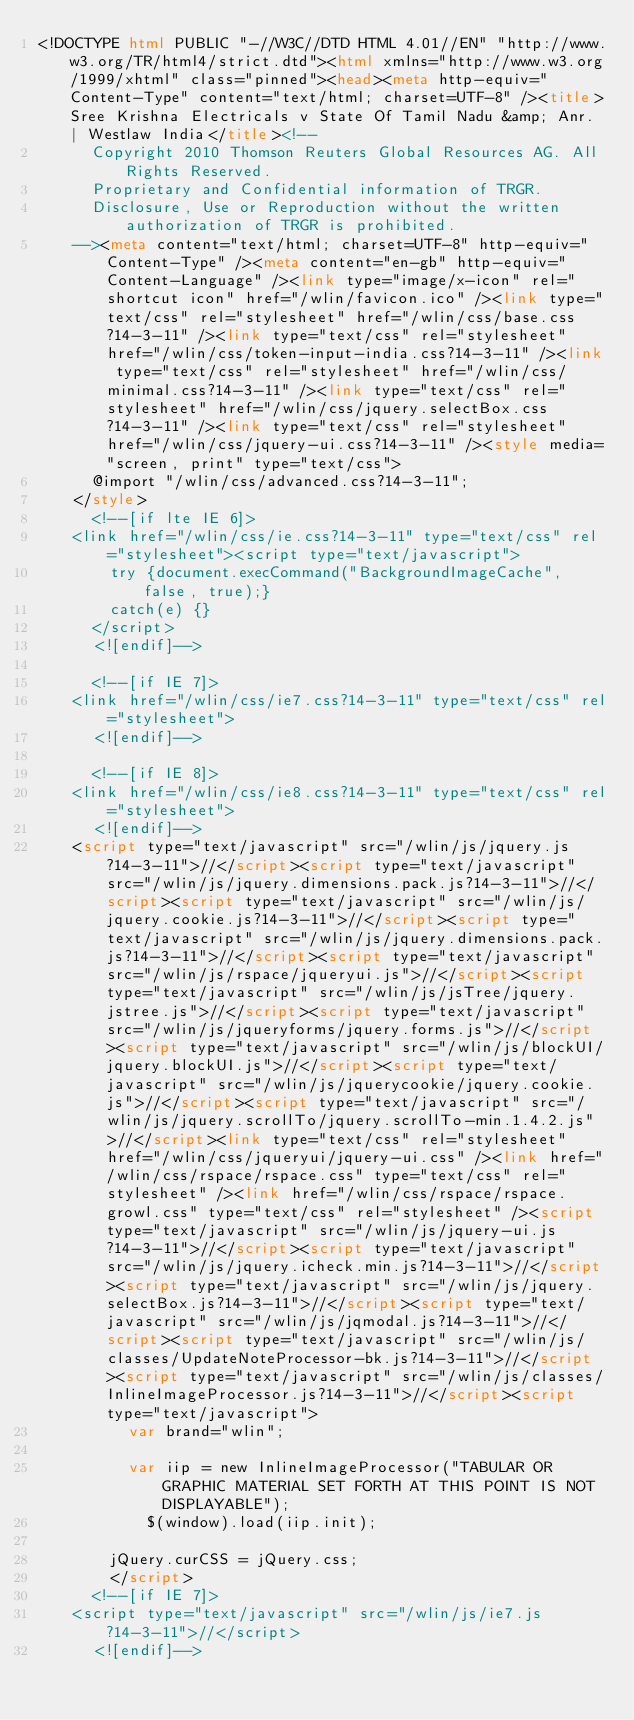Convert code to text. <code><loc_0><loc_0><loc_500><loc_500><_HTML_><!DOCTYPE html PUBLIC "-//W3C//DTD HTML 4.01//EN" "http://www.w3.org/TR/html4/strict.dtd"><html xmlns="http://www.w3.org/1999/xhtml" class="pinned"><head><meta http-equiv="Content-Type" content="text/html; charset=UTF-8" /><title>Sree Krishna Electricals v State Of Tamil Nadu &amp; Anr. | Westlaw India</title><!--
      Copyright 2010 Thomson Reuters Global Resources AG. All Rights Reserved.
      Proprietary and Confidential information of TRGR.
      Disclosure, Use or Reproduction without the written authorization of TRGR is prohibited.
    --><meta content="text/html; charset=UTF-8" http-equiv="Content-Type" /><meta content="en-gb" http-equiv="Content-Language" /><link type="image/x-icon" rel="shortcut icon" href="/wlin/favicon.ico" /><link type="text/css" rel="stylesheet" href="/wlin/css/base.css?14-3-11" /><link type="text/css" rel="stylesheet" href="/wlin/css/token-input-india.css?14-3-11" /><link type="text/css" rel="stylesheet" href="/wlin/css/minimal.css?14-3-11" /><link type="text/css" rel="stylesheet" href="/wlin/css/jquery.selectBox.css?14-3-11" /><link type="text/css" rel="stylesheet" href="/wlin/css/jquery-ui.css?14-3-11" /><style media="screen, print" type="text/css">
			@import "/wlin/css/advanced.css?14-3-11";
		</style>
			<!--[if lte IE 6]>
		<link href="/wlin/css/ie.css?14-3-11" type="text/css" rel="stylesheet"><script type="text/javascript">
				try {document.execCommand("BackgroundImageCache", false, true);}
				catch(e) {}
			</script>
			<![endif]-->
		
			<!--[if IE 7]>
		<link href="/wlin/css/ie7.css?14-3-11" type="text/css" rel="stylesheet">
			<![endif]-->
		
			<!--[if IE 8]>
		<link href="/wlin/css/ie8.css?14-3-11" type="text/css" rel="stylesheet">
			<![endif]-->
		<script type="text/javascript" src="/wlin/js/jquery.js?14-3-11">//</script><script type="text/javascript" src="/wlin/js/jquery.dimensions.pack.js?14-3-11">//</script><script type="text/javascript" src="/wlin/js/jquery.cookie.js?14-3-11">//</script><script type="text/javascript" src="/wlin/js/jquery.dimensions.pack.js?14-3-11">//</script><script type="text/javascript" src="/wlin/js/rspace/jqueryui.js">//</script><script type="text/javascript" src="/wlin/js/jsTree/jquery.jstree.js">//</script><script type="text/javascript" src="/wlin/js/jqueryforms/jquery.forms.js">//</script><script type="text/javascript" src="/wlin/js/blockUI/jquery.blockUI.js">//</script><script type="text/javascript" src="/wlin/js/jquerycookie/jquery.cookie.js">//</script><script type="text/javascript" src="/wlin/js/jquery.scrollTo/jquery.scrollTo-min.1.4.2.js">//</script><link type="text/css" rel="stylesheet" href="/wlin/css/jqueryui/jquery-ui.css" /><link href="/wlin/css/rspace/rspace.css" type="text/css" rel="stylesheet" /><link href="/wlin/css/rspace/rspace.growl.css" type="text/css" rel="stylesheet" /><script type="text/javascript" src="/wlin/js/jquery-ui.js?14-3-11">//</script><script type="text/javascript" src="/wlin/js/jquery.icheck.min.js?14-3-11">//</script><script type="text/javascript" src="/wlin/js/jquery.selectBox.js?14-3-11">//</script><script type="text/javascript" src="/wlin/js/jqmodal.js?14-3-11">//</script><script type="text/javascript" src="/wlin/js/classes/UpdateNoteProcessor-bk.js?14-3-11">//</script><script type="text/javascript" src="/wlin/js/classes/InlineImageProcessor.js?14-3-11">//</script><script type="text/javascript">
        	var brand="wlin";
        	
        	var iip = new InlineImageProcessor("TABULAR OR GRAPHIC MATERIAL SET FORTH AT THIS POINT IS NOT DISPLAYABLE"); 
            $(window).load(iip.init);
            
    		jQuery.curCSS = jQuery.css;
        </script>
			<!--[if IE 7]>
		<script type="text/javascript" src="/wlin/js/ie7.js?14-3-11">//</script>
			<![endif]--></code> 